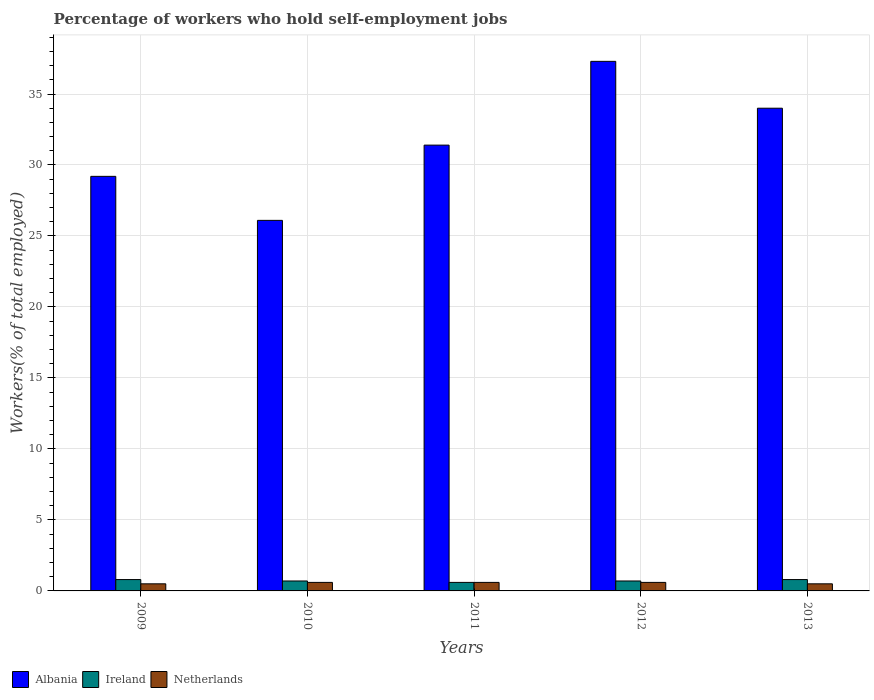Are the number of bars per tick equal to the number of legend labels?
Your answer should be very brief. Yes. In how many cases, is the number of bars for a given year not equal to the number of legend labels?
Your answer should be compact. 0. Across all years, what is the maximum percentage of self-employed workers in Netherlands?
Keep it short and to the point. 0.6. Across all years, what is the minimum percentage of self-employed workers in Albania?
Make the answer very short. 26.1. In which year was the percentage of self-employed workers in Albania maximum?
Your answer should be compact. 2012. What is the total percentage of self-employed workers in Ireland in the graph?
Your answer should be compact. 3.6. What is the difference between the percentage of self-employed workers in Albania in 2010 and that in 2013?
Give a very brief answer. -7.9. What is the difference between the percentage of self-employed workers in Albania in 2011 and the percentage of self-employed workers in Netherlands in 2012?
Your answer should be compact. 30.8. What is the average percentage of self-employed workers in Ireland per year?
Give a very brief answer. 0.72. In the year 2013, what is the difference between the percentage of self-employed workers in Netherlands and percentage of self-employed workers in Albania?
Provide a succinct answer. -33.5. In how many years, is the percentage of self-employed workers in Netherlands greater than 33 %?
Your answer should be compact. 0. What is the ratio of the percentage of self-employed workers in Albania in 2009 to that in 2010?
Offer a terse response. 1.12. What is the difference between the highest and the lowest percentage of self-employed workers in Ireland?
Your answer should be compact. 0.2. What does the 2nd bar from the right in 2010 represents?
Provide a short and direct response. Ireland. How many bars are there?
Provide a short and direct response. 15. How many years are there in the graph?
Your response must be concise. 5. Does the graph contain any zero values?
Offer a terse response. No. Does the graph contain grids?
Provide a short and direct response. Yes. What is the title of the graph?
Ensure brevity in your answer.  Percentage of workers who hold self-employment jobs. What is the label or title of the Y-axis?
Your response must be concise. Workers(% of total employed). What is the Workers(% of total employed) in Albania in 2009?
Offer a terse response. 29.2. What is the Workers(% of total employed) in Ireland in 2009?
Ensure brevity in your answer.  0.8. What is the Workers(% of total employed) of Albania in 2010?
Offer a very short reply. 26.1. What is the Workers(% of total employed) of Ireland in 2010?
Your response must be concise. 0.7. What is the Workers(% of total employed) of Netherlands in 2010?
Keep it short and to the point. 0.6. What is the Workers(% of total employed) in Albania in 2011?
Provide a short and direct response. 31.4. What is the Workers(% of total employed) in Ireland in 2011?
Your response must be concise. 0.6. What is the Workers(% of total employed) in Netherlands in 2011?
Your response must be concise. 0.6. What is the Workers(% of total employed) in Albania in 2012?
Provide a succinct answer. 37.3. What is the Workers(% of total employed) of Ireland in 2012?
Offer a very short reply. 0.7. What is the Workers(% of total employed) of Netherlands in 2012?
Your answer should be very brief. 0.6. What is the Workers(% of total employed) of Ireland in 2013?
Keep it short and to the point. 0.8. What is the Workers(% of total employed) of Netherlands in 2013?
Offer a very short reply. 0.5. Across all years, what is the maximum Workers(% of total employed) of Albania?
Give a very brief answer. 37.3. Across all years, what is the maximum Workers(% of total employed) in Ireland?
Your answer should be compact. 0.8. Across all years, what is the maximum Workers(% of total employed) in Netherlands?
Give a very brief answer. 0.6. Across all years, what is the minimum Workers(% of total employed) in Albania?
Ensure brevity in your answer.  26.1. Across all years, what is the minimum Workers(% of total employed) of Ireland?
Keep it short and to the point. 0.6. What is the total Workers(% of total employed) of Albania in the graph?
Offer a very short reply. 158. What is the total Workers(% of total employed) in Ireland in the graph?
Your response must be concise. 3.6. What is the total Workers(% of total employed) of Netherlands in the graph?
Your answer should be compact. 2.8. What is the difference between the Workers(% of total employed) of Albania in 2009 and that in 2010?
Offer a terse response. 3.1. What is the difference between the Workers(% of total employed) of Albania in 2009 and that in 2011?
Offer a very short reply. -2.2. What is the difference between the Workers(% of total employed) in Ireland in 2009 and that in 2011?
Provide a succinct answer. 0.2. What is the difference between the Workers(% of total employed) of Netherlands in 2009 and that in 2011?
Your answer should be very brief. -0.1. What is the difference between the Workers(% of total employed) of Albania in 2009 and that in 2012?
Keep it short and to the point. -8.1. What is the difference between the Workers(% of total employed) in Ireland in 2009 and that in 2012?
Your answer should be very brief. 0.1. What is the difference between the Workers(% of total employed) of Netherlands in 2009 and that in 2012?
Your response must be concise. -0.1. What is the difference between the Workers(% of total employed) in Albania in 2009 and that in 2013?
Provide a short and direct response. -4.8. What is the difference between the Workers(% of total employed) in Ireland in 2009 and that in 2013?
Give a very brief answer. 0. What is the difference between the Workers(% of total employed) in Netherlands in 2009 and that in 2013?
Your answer should be very brief. 0. What is the difference between the Workers(% of total employed) of Albania in 2010 and that in 2011?
Offer a very short reply. -5.3. What is the difference between the Workers(% of total employed) in Ireland in 2010 and that in 2011?
Your response must be concise. 0.1. What is the difference between the Workers(% of total employed) of Ireland in 2010 and that in 2013?
Ensure brevity in your answer.  -0.1. What is the difference between the Workers(% of total employed) of Netherlands in 2010 and that in 2013?
Your answer should be very brief. 0.1. What is the difference between the Workers(% of total employed) of Albania in 2011 and that in 2012?
Keep it short and to the point. -5.9. What is the difference between the Workers(% of total employed) of Netherlands in 2011 and that in 2012?
Your answer should be very brief. 0. What is the difference between the Workers(% of total employed) in Albania in 2011 and that in 2013?
Make the answer very short. -2.6. What is the difference between the Workers(% of total employed) in Ireland in 2011 and that in 2013?
Make the answer very short. -0.2. What is the difference between the Workers(% of total employed) in Albania in 2012 and that in 2013?
Provide a short and direct response. 3.3. What is the difference between the Workers(% of total employed) in Albania in 2009 and the Workers(% of total employed) in Netherlands in 2010?
Ensure brevity in your answer.  28.6. What is the difference between the Workers(% of total employed) of Ireland in 2009 and the Workers(% of total employed) of Netherlands in 2010?
Your response must be concise. 0.2. What is the difference between the Workers(% of total employed) of Albania in 2009 and the Workers(% of total employed) of Ireland in 2011?
Offer a very short reply. 28.6. What is the difference between the Workers(% of total employed) in Albania in 2009 and the Workers(% of total employed) in Netherlands in 2011?
Provide a succinct answer. 28.6. What is the difference between the Workers(% of total employed) of Ireland in 2009 and the Workers(% of total employed) of Netherlands in 2011?
Give a very brief answer. 0.2. What is the difference between the Workers(% of total employed) of Albania in 2009 and the Workers(% of total employed) of Ireland in 2012?
Keep it short and to the point. 28.5. What is the difference between the Workers(% of total employed) of Albania in 2009 and the Workers(% of total employed) of Netherlands in 2012?
Make the answer very short. 28.6. What is the difference between the Workers(% of total employed) of Albania in 2009 and the Workers(% of total employed) of Ireland in 2013?
Provide a short and direct response. 28.4. What is the difference between the Workers(% of total employed) of Albania in 2009 and the Workers(% of total employed) of Netherlands in 2013?
Provide a succinct answer. 28.7. What is the difference between the Workers(% of total employed) in Albania in 2010 and the Workers(% of total employed) in Ireland in 2011?
Give a very brief answer. 25.5. What is the difference between the Workers(% of total employed) of Albania in 2010 and the Workers(% of total employed) of Netherlands in 2011?
Offer a terse response. 25.5. What is the difference between the Workers(% of total employed) of Ireland in 2010 and the Workers(% of total employed) of Netherlands in 2011?
Keep it short and to the point. 0.1. What is the difference between the Workers(% of total employed) in Albania in 2010 and the Workers(% of total employed) in Ireland in 2012?
Provide a succinct answer. 25.4. What is the difference between the Workers(% of total employed) in Ireland in 2010 and the Workers(% of total employed) in Netherlands in 2012?
Ensure brevity in your answer.  0.1. What is the difference between the Workers(% of total employed) of Albania in 2010 and the Workers(% of total employed) of Ireland in 2013?
Ensure brevity in your answer.  25.3. What is the difference between the Workers(% of total employed) in Albania in 2010 and the Workers(% of total employed) in Netherlands in 2013?
Keep it short and to the point. 25.6. What is the difference between the Workers(% of total employed) in Ireland in 2010 and the Workers(% of total employed) in Netherlands in 2013?
Your response must be concise. 0.2. What is the difference between the Workers(% of total employed) in Albania in 2011 and the Workers(% of total employed) in Ireland in 2012?
Provide a short and direct response. 30.7. What is the difference between the Workers(% of total employed) in Albania in 2011 and the Workers(% of total employed) in Netherlands in 2012?
Provide a short and direct response. 30.8. What is the difference between the Workers(% of total employed) in Ireland in 2011 and the Workers(% of total employed) in Netherlands in 2012?
Your response must be concise. 0. What is the difference between the Workers(% of total employed) of Albania in 2011 and the Workers(% of total employed) of Ireland in 2013?
Make the answer very short. 30.6. What is the difference between the Workers(% of total employed) in Albania in 2011 and the Workers(% of total employed) in Netherlands in 2013?
Keep it short and to the point. 30.9. What is the difference between the Workers(% of total employed) in Ireland in 2011 and the Workers(% of total employed) in Netherlands in 2013?
Provide a short and direct response. 0.1. What is the difference between the Workers(% of total employed) of Albania in 2012 and the Workers(% of total employed) of Ireland in 2013?
Your response must be concise. 36.5. What is the difference between the Workers(% of total employed) in Albania in 2012 and the Workers(% of total employed) in Netherlands in 2013?
Make the answer very short. 36.8. What is the average Workers(% of total employed) in Albania per year?
Keep it short and to the point. 31.6. What is the average Workers(% of total employed) of Ireland per year?
Keep it short and to the point. 0.72. What is the average Workers(% of total employed) in Netherlands per year?
Keep it short and to the point. 0.56. In the year 2009, what is the difference between the Workers(% of total employed) of Albania and Workers(% of total employed) of Ireland?
Offer a terse response. 28.4. In the year 2009, what is the difference between the Workers(% of total employed) in Albania and Workers(% of total employed) in Netherlands?
Provide a succinct answer. 28.7. In the year 2009, what is the difference between the Workers(% of total employed) in Ireland and Workers(% of total employed) in Netherlands?
Offer a very short reply. 0.3. In the year 2010, what is the difference between the Workers(% of total employed) of Albania and Workers(% of total employed) of Ireland?
Offer a very short reply. 25.4. In the year 2011, what is the difference between the Workers(% of total employed) of Albania and Workers(% of total employed) of Ireland?
Keep it short and to the point. 30.8. In the year 2011, what is the difference between the Workers(% of total employed) in Albania and Workers(% of total employed) in Netherlands?
Provide a succinct answer. 30.8. In the year 2011, what is the difference between the Workers(% of total employed) in Ireland and Workers(% of total employed) in Netherlands?
Give a very brief answer. 0. In the year 2012, what is the difference between the Workers(% of total employed) in Albania and Workers(% of total employed) in Ireland?
Give a very brief answer. 36.6. In the year 2012, what is the difference between the Workers(% of total employed) in Albania and Workers(% of total employed) in Netherlands?
Your answer should be very brief. 36.7. In the year 2013, what is the difference between the Workers(% of total employed) in Albania and Workers(% of total employed) in Ireland?
Your answer should be compact. 33.2. In the year 2013, what is the difference between the Workers(% of total employed) of Albania and Workers(% of total employed) of Netherlands?
Make the answer very short. 33.5. In the year 2013, what is the difference between the Workers(% of total employed) in Ireland and Workers(% of total employed) in Netherlands?
Offer a terse response. 0.3. What is the ratio of the Workers(% of total employed) in Albania in 2009 to that in 2010?
Give a very brief answer. 1.12. What is the ratio of the Workers(% of total employed) of Albania in 2009 to that in 2011?
Your response must be concise. 0.93. What is the ratio of the Workers(% of total employed) of Netherlands in 2009 to that in 2011?
Keep it short and to the point. 0.83. What is the ratio of the Workers(% of total employed) in Albania in 2009 to that in 2012?
Your answer should be very brief. 0.78. What is the ratio of the Workers(% of total employed) of Ireland in 2009 to that in 2012?
Your response must be concise. 1.14. What is the ratio of the Workers(% of total employed) in Albania in 2009 to that in 2013?
Your response must be concise. 0.86. What is the ratio of the Workers(% of total employed) in Netherlands in 2009 to that in 2013?
Ensure brevity in your answer.  1. What is the ratio of the Workers(% of total employed) of Albania in 2010 to that in 2011?
Offer a terse response. 0.83. What is the ratio of the Workers(% of total employed) in Netherlands in 2010 to that in 2011?
Keep it short and to the point. 1. What is the ratio of the Workers(% of total employed) in Albania in 2010 to that in 2012?
Provide a short and direct response. 0.7. What is the ratio of the Workers(% of total employed) of Netherlands in 2010 to that in 2012?
Offer a very short reply. 1. What is the ratio of the Workers(% of total employed) in Albania in 2010 to that in 2013?
Your answer should be very brief. 0.77. What is the ratio of the Workers(% of total employed) in Ireland in 2010 to that in 2013?
Provide a succinct answer. 0.88. What is the ratio of the Workers(% of total employed) of Albania in 2011 to that in 2012?
Make the answer very short. 0.84. What is the ratio of the Workers(% of total employed) in Netherlands in 2011 to that in 2012?
Keep it short and to the point. 1. What is the ratio of the Workers(% of total employed) of Albania in 2011 to that in 2013?
Ensure brevity in your answer.  0.92. What is the ratio of the Workers(% of total employed) of Netherlands in 2011 to that in 2013?
Keep it short and to the point. 1.2. What is the ratio of the Workers(% of total employed) of Albania in 2012 to that in 2013?
Your response must be concise. 1.1. What is the ratio of the Workers(% of total employed) in Ireland in 2012 to that in 2013?
Your answer should be very brief. 0.88. What is the difference between the highest and the second highest Workers(% of total employed) of Netherlands?
Your answer should be very brief. 0. What is the difference between the highest and the lowest Workers(% of total employed) of Albania?
Offer a very short reply. 11.2. 